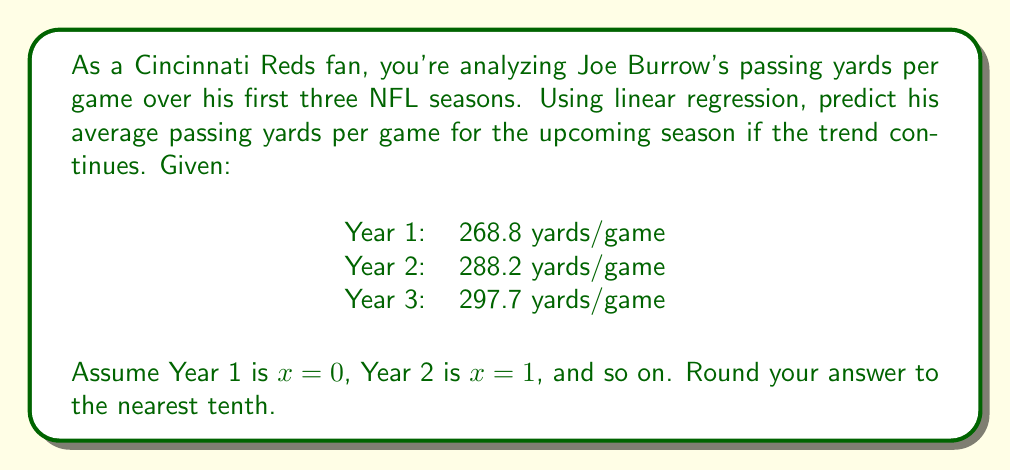Can you solve this math problem? To solve this problem, we'll use linear regression to find the line of best fit for the given data points and then use it to predict the value for Year 4 (x = 3).

1. First, let's set up our data points:
   (0, 268.8), (1, 288.2), (2, 297.7)

2. We'll use the formula for the slope (m) of the line of best fit:
   $$m = \frac{n\sum xy - \sum x \sum y}{n\sum x^2 - (\sum x)^2}$$

   Where n is the number of data points.

3. Calculate the necessary sums:
   $\sum x = 0 + 1 + 2 = 3$
   $\sum y = 268.8 + 288.2 + 297.7 = 854.7$
   $\sum xy = 0(268.8) + 1(288.2) + 2(297.7) = 883.6$
   $\sum x^2 = 0^2 + 1^2 + 2^2 = 5$

4. Plug these values into the slope formula:
   $$m = \frac{3(883.6) - 3(854.7)}{3(5) - 3^2} = \frac{2650.8 - 2564.1}{15 - 9} = \frac{86.7}{6} = 14.45$$

5. Now we can find the y-intercept (b) using the formula:
   $$b = \bar{y} - m\bar{x}$$
   Where $\bar{y}$ is the mean of y values and $\bar{x}$ is the mean of x values.

   $\bar{y} = 854.7 / 3 = 284.9$
   $\bar{x} = 3 / 3 = 1$

   $$b = 284.9 - 14.45(1) = 270.45$$

6. Our line of best fit equation is:
   $$y = 14.45x + 270.45$$

7. To predict Year 4 (x = 3), we plug in x = 3:
   $$y = 14.45(3) + 270.45 = 313.8$$

Therefore, the predicted average passing yards per game for Year 4 is 313.8 yards.
Answer: 313.8 yards per game 